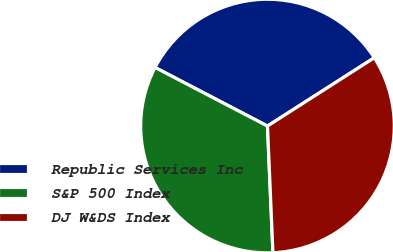Convert chart. <chart><loc_0><loc_0><loc_500><loc_500><pie_chart><fcel>Republic Services Inc<fcel>S&P 500 Index<fcel>DJ W&DS Index<nl><fcel>33.3%<fcel>33.33%<fcel>33.37%<nl></chart> 